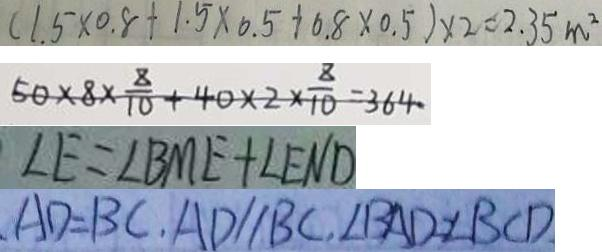Convert formula to latex. <formula><loc_0><loc_0><loc_500><loc_500>( 1 . 5 \times 0 . 8 + 1 . 5 \times 0 . 5 + 0 . 8 \times 0 . 5 ) \times 2 = 2 . 3 5 m ^ { 2 } 
 5 0 \times 8 \times \frac { 8 } { 1 0 } + 4 0 \times 2 \times \frac { 8 } { 1 0 } = 3 6 4 
 \angle E = \angle B M E + \angle E N D 
 A D = B C , A D / / B C , \angle B A D = \angle B C D</formula> 